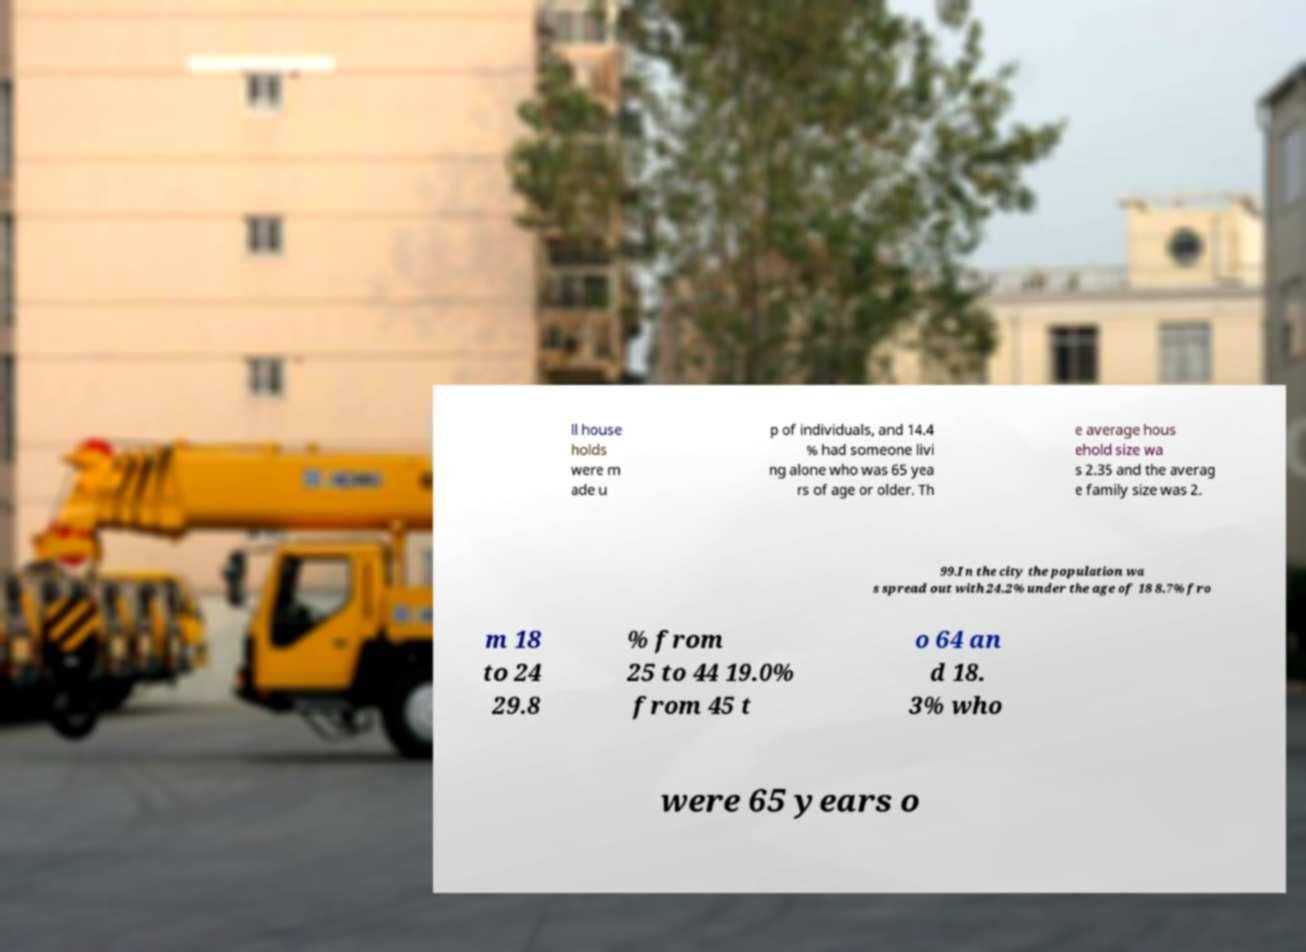Please identify and transcribe the text found in this image. ll house holds were m ade u p of individuals, and 14.4 % had someone livi ng alone who was 65 yea rs of age or older. Th e average hous ehold size wa s 2.35 and the averag e family size was 2. 99.In the city the population wa s spread out with 24.2% under the age of 18 8.7% fro m 18 to 24 29.8 % from 25 to 44 19.0% from 45 t o 64 an d 18. 3% who were 65 years o 